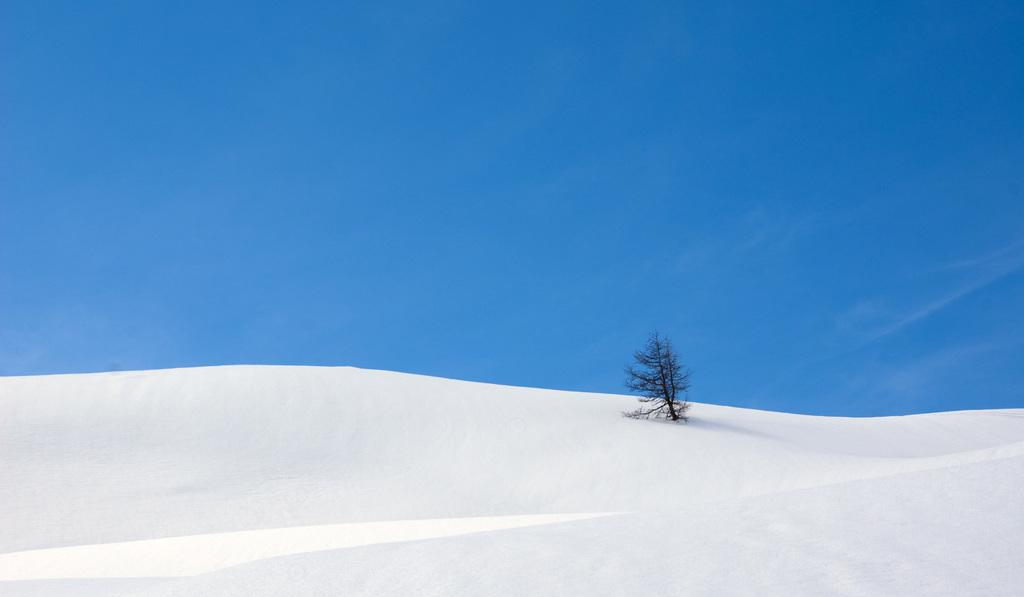Where was the image taken? The image is taken outdoors. What can be seen at the top of the image? The sky is visible at the top of the image. What is present at the bottom of the image? There is snow at the bottom of the image. What is located in the middle of the image? There is a tree in the middle of the image. What type of stew is being prepared in the image? There is no stew present in the image; it features a tree, snow, and the sky. What kind of bait is visible on the tree in the image? There is no bait present on the tree in the image; it is a tree with snow around it. 